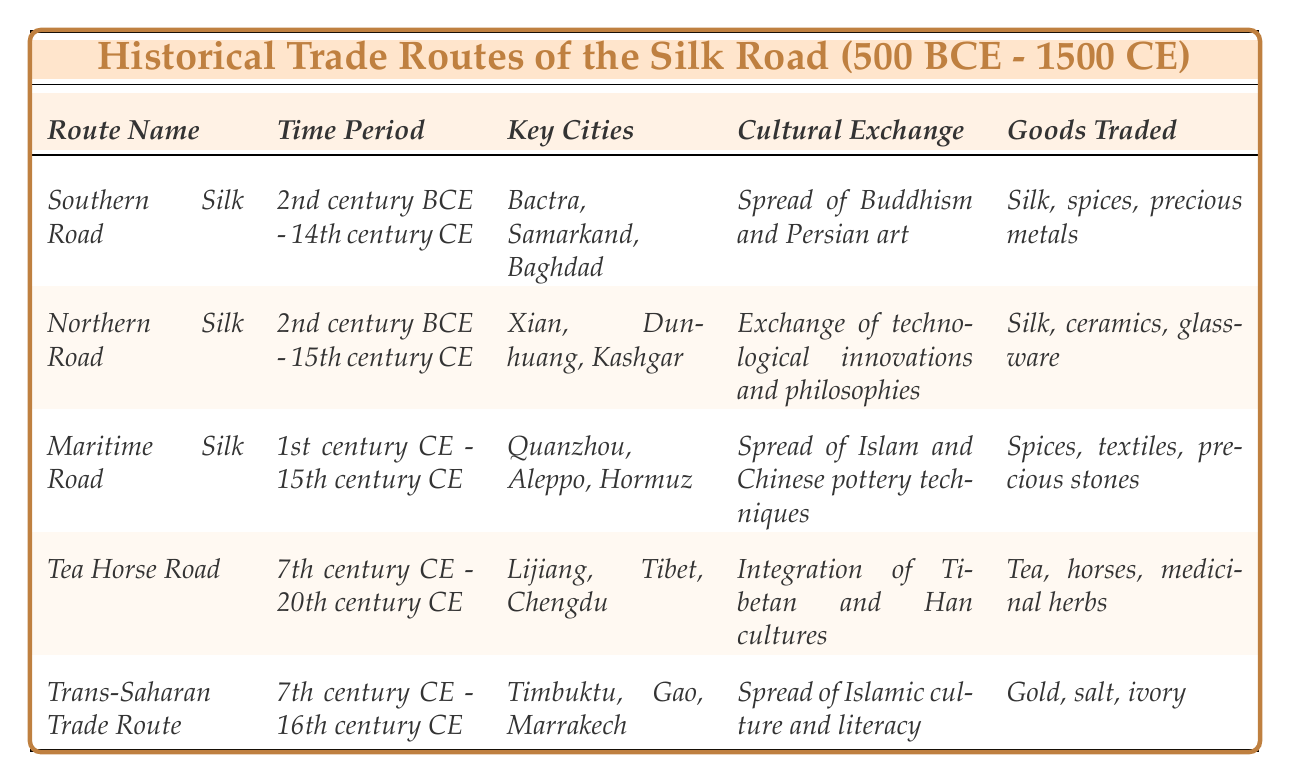What are the key cities along the Southern Silk Road? The table lists the key cities of the Southern Silk Road as Bactra, Samarkand, and Baghdad. This information is found directly in the corresponding column for the Southern Silk Road.
Answer: Bactra, Samarkand, Baghdad Which trade route was active from the 7th century CE to the 20th century CE? The Tea Horse Road is the only route that spans from the 7th century CE to the 20th century CE, as specified in the Time Period column.
Answer: Tea Horse Road What goods were traded along the Maritime Silk Road? According to the table, the goods traded along the Maritime Silk Road included spices, textiles, and precious stones. This can be found in the Goods Traded column for that route.
Answer: Spices, textiles, precious stones Did the Northern Silk Road facilitate the exchange of philosophies? Yes, the table states that the Northern Silk Road facilitated the exchange of technological innovations and philosophies, confirming the statement is true.
Answer: Yes Which route involved the integration of Tibetan and Han cultures? The Tea Horse Road involved the integration of Tibetan and Han cultures, as noted in the Cultural Exchange column for that route.
Answer: Tea Horse Road Compare the time periods of the Southern Silk Road and the Northern Silk Road. The Southern Silk Road was active from the 2nd century BCE to the 14th century CE, while the Northern Silk Road was active from the 2nd century BCE to the 15th century CE. The Southern Silk Road ends earlier than the Northern Silk Road, by one century.
Answer: Southern ends in the 14th century, Northern in the 15th century Which trade route is associated with the spread of Buddhism? The Southern Silk Road is associated with the spread of Buddhism and Persian art, which is explicitly mentioned in the Cultural Exchange column.
Answer: Southern Silk Road Identify the trade route that predominantly traded gold, salt, and ivory. The Trans-Saharan Trade Route is the trade route that predominantly traded gold, salt, and ivory, as indicated in the Goods Traded column.
Answer: Trans-Saharan Trade Route What is the pattern observed in the time periods for the Maritime Silk Road and Tea Horse Road? Both routes have overlapping time periods within the 1st century CE to the 20th century CE, meaning they were operational during some of the same centuries.
Answer: Overlapping periods Which trade route had the most diverse cultural exchanges? The Northern Silk Road had diverse cultural exchanges such as the exchange of technological innovations and philosophies, as compared to other routes with more specific exchanges. This is noted in the Cultural Exchange column.
Answer: Northern Silk Road 